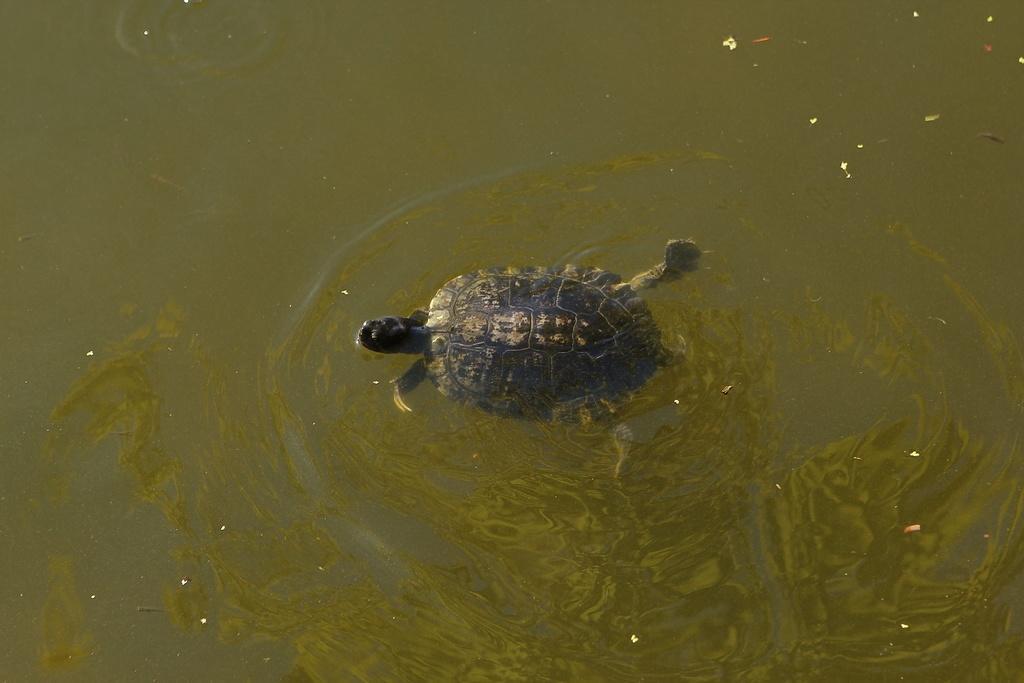Could you give a brief overview of what you see in this image? There is a tortoise swimming in the water. 